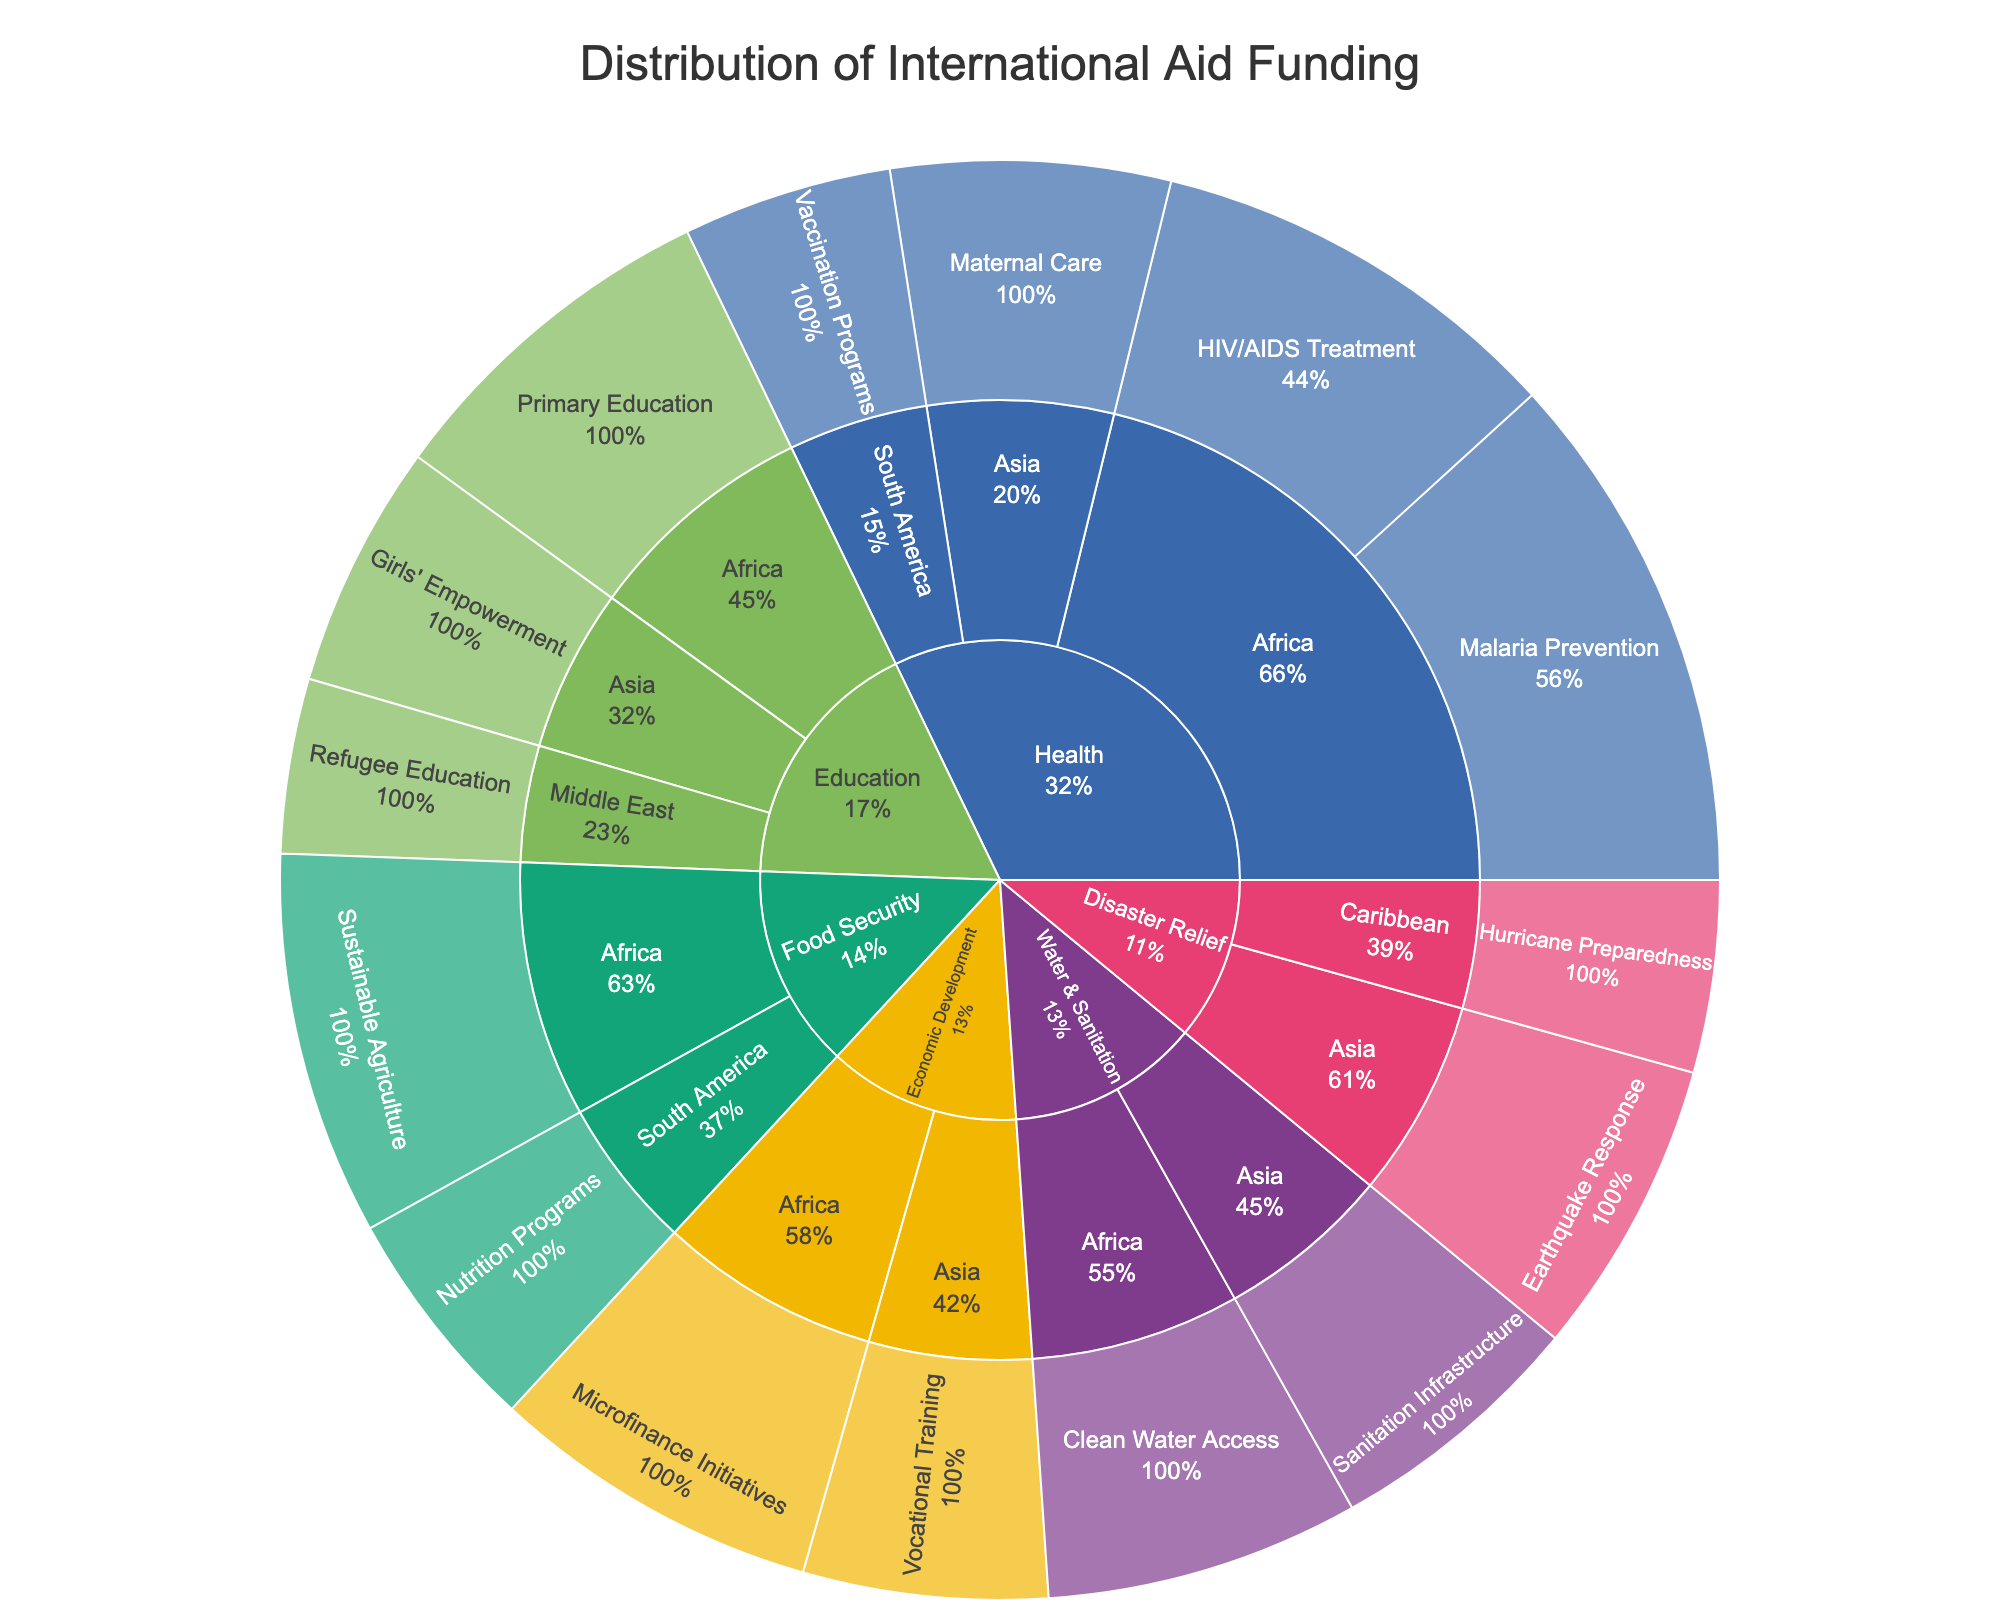Which sector received the highest total funding? First, look at the central node of the Sunburst Plot to identify the sectors. Compare the size of each sector's segment to determine which one is the largest. The Health sector has the largest segment.
Answer: Health What is the total funding allocated to the Asia region? Identify all Asia nodes within each sector and sum their corresponding funding values. From the chart: Health (Maternal Care: $80,000,000), Water & Sanitation (Sanitation Infrastructure: $75,000,000), Disaster Relief (Earthquake Response: $85,000,000), Economic Development (Vocational Training: $70,000,000), Education (Girls' Empowerment: $70,000,000). Total funding is $80,000,000 + $75,000,000 + $85,000,000 + $70,000,000 + $70,000,000 = $380,000,000.
Answer: $380,000,000 Which program received the most funding in the Africa region? Navigate to the Africa region nodes under each sector and compare the funding amounts of programs. The Malaria Prevention program under the Health sector has the largest funding at $150,000,000.
Answer: Malaria Prevention Compare the funding for Primary Education in Africa and Refugee Education in the Middle East. Which one received more funding and by how much? Find both Primary Education in Africa ($100,000,000) and Refugee Education in the Middle East ($50,000,000). Calculate the difference: $100,000,000 - $50,000,000 = $50,000,000.
Answer: Primary Education in Africa, $50,000,000 What percentage of the total funding was allocated to the Health sector? Determine the funding for the Health sector by summing up its program funding (Malaria Prevention: $150,000,000, HIV/AIDS Treatment: $120,000,000, Maternal Care: $80,000,000, Vaccination Programs: $60,000,000). Total Health funding is $150,000,000 + $120,000,000 + $80,000,000 + $60,000,000 = $410,000,000. Calculate the total funding from all sectors which is $1,250,000,000 (sum of all program funding). The percentage is ($410,000,000 / $1,250,000,000) * 100 = 32.8%.
Answer: 32.8% Which region has the second highest total funding and what is the amount? Calculate total funding for each region: Africa ($150,000,000 + $120,000,000 + $100,000,000 + $90,000,000 + $110,000,000 + $95,000,000 = $665,000,000), Asia ($80,000,000 + $75,000,000 + $85,000,000 + $70,000,000 + $70,000,000 = $380,000,000), South America ($60,000,000 + $65,000,000 = $125,000,000), Middle East ($50,000,000), Caribbean ($55,000,000). Africa has the highest, Asia has the second highest at $380,000,000.
Answer: Asia, $380,000,000 How many programs are funded under the Water & Sanitation sector? Locate the Water & Sanitation sector and count the programs listed under it. There are two programs: Clean Water Access in Africa, and Sanitation Infrastructure in Asia.
Answer: 2 Which sector received the least funding and what is the total amount? Calculate the total funding for each sector: Health ($410,000,000), Education ($220,000,000), Water & Sanitation ($165,000,000), Food Security ($175,000,000), Disaster Relief ($140,000,000), Economic Development ($165,000,000). Disaster Relief has the least funding at $140,000,000.
Answer: Disaster Relief, $140,000,000 What is the total combined funding for programs under the Education sector in the Middle East and Asia? Identify Education programs in the Middle East (Refugee Education: $50,000,000) and Asia (Girls' Empowerment: $70,000,000). Total combined funding is $50,000,000 + $70,000,000 = $120,000,000.
Answer: $120,000,000 